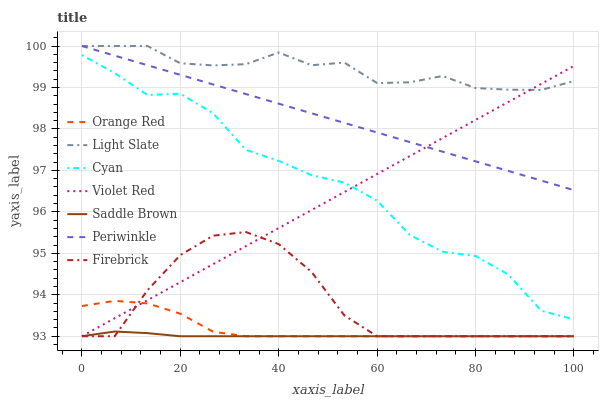Does Saddle Brown have the minimum area under the curve?
Answer yes or no. Yes. Does Light Slate have the maximum area under the curve?
Answer yes or no. Yes. Does Firebrick have the minimum area under the curve?
Answer yes or no. No. Does Firebrick have the maximum area under the curve?
Answer yes or no. No. Is Periwinkle the smoothest?
Answer yes or no. Yes. Is Cyan the roughest?
Answer yes or no. Yes. Is Light Slate the smoothest?
Answer yes or no. No. Is Light Slate the roughest?
Answer yes or no. No. Does Violet Red have the lowest value?
Answer yes or no. Yes. Does Light Slate have the lowest value?
Answer yes or no. No. Does Periwinkle have the highest value?
Answer yes or no. Yes. Does Firebrick have the highest value?
Answer yes or no. No. Is Cyan less than Periwinkle?
Answer yes or no. Yes. Is Cyan greater than Orange Red?
Answer yes or no. Yes. Does Light Slate intersect Violet Red?
Answer yes or no. Yes. Is Light Slate less than Violet Red?
Answer yes or no. No. Is Light Slate greater than Violet Red?
Answer yes or no. No. Does Cyan intersect Periwinkle?
Answer yes or no. No. 